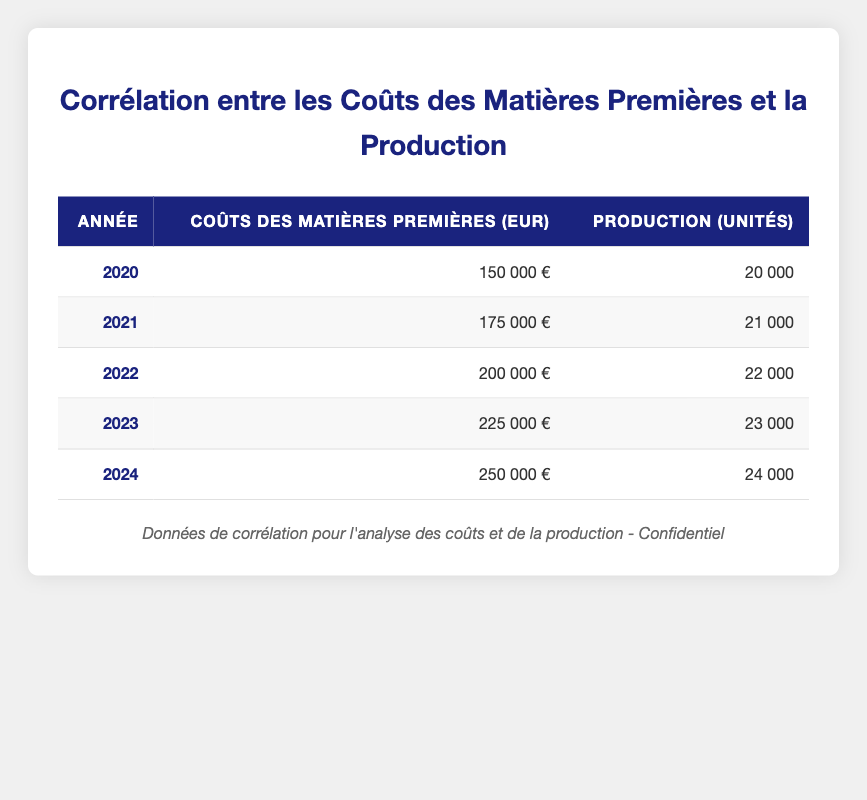What were the raw material costs in 2021? The table shows that in 2021, the raw material costs were listed under the corresponding year as 175,000 EUR.
Answer: 175000 EUR In which year was the production output the highest? To find the highest production output, I compare all the production output units across the years. The maximum output is 24,000 units in 2024.
Answer: 2024 What is the total increase in raw material costs from 2020 to 2024? The raw material costs in 2020 were 150,000 EUR and in 2024 were 250,000 EUR. The increase is calculated as 250,000 - 150,000 = 100,000 EUR.
Answer: 100000 EUR Is it true that production output decreased from 2023 to 2024? To verify, I check the production output for both years. In 2023, it was 23,000 units and in 2024, it was 24,000 units, which means production output actually increased.
Answer: No What is the average production output over the years from 2020 to 2024? I need to sum the production output for each year: 20,000 + 21,000 + 22,000 + 23,000 + 24,000 = 110,000. Then, I divide by the 5 years, which gives 110,000 / 5 = 22,000 units.
Answer: 22000 units If raw material costs continue to increase at the same rate as from 2020 to 2023, what would be the expected costs for 2025? Calculating the annual increase from 2020 to 2023: 150,000 EUR in 2020 to 225,000 EUR in 2023 is an increase of 75,000 EUR over 3 years, averaging 25,000 EUR per year. Adding this to 225,000 EUR for 2024 gives an estimate of 250,000 EUR for 2025.
Answer: 250000 EUR What is the total production output for the years 2020 to 2022? I sum the production outputs for these years: 20,000 + 21,000 + 22,000 = 63,000 units.
Answer: 63000 units Did the production output grow each year from 2020 to 2024? By examining each year's production output, I see it went from 20,000 in 2020 to 24,000 in 2024, indicating continuous growth: 20,000 < 21,000 < 22,000 < 23,000 < 24,000.
Answer: Yes 